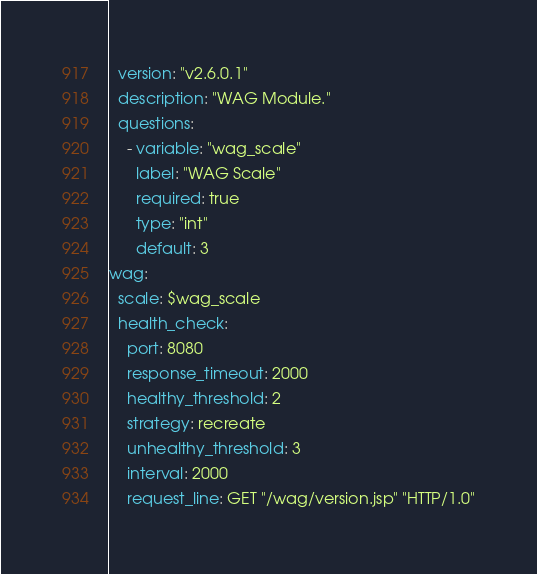<code> <loc_0><loc_0><loc_500><loc_500><_YAML_>  version: "v2.6.0.1"
  description: "WAG Module."
  questions:
    - variable: "wag_scale"
      label: "WAG Scale"
      required: true
      type: "int"
      default: 3
wag:
  scale: $wag_scale
  health_check:
    port: 8080
    response_timeout: 2000
    healthy_threshold: 2
    strategy: recreate
    unhealthy_threshold: 3
    interval: 2000
    request_line: GET "/wag/version.jsp" "HTTP/1.0"
</code> 